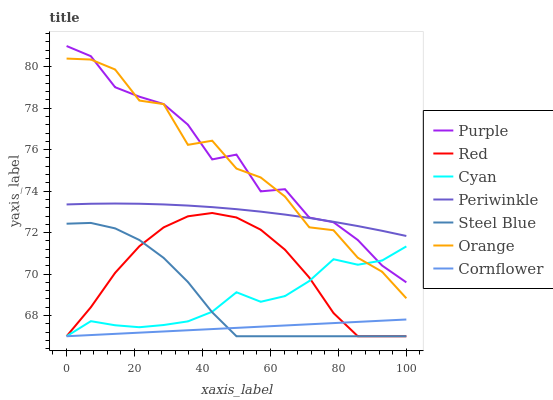Does Cornflower have the minimum area under the curve?
Answer yes or no. Yes. Does Purple have the maximum area under the curve?
Answer yes or no. Yes. Does Steel Blue have the minimum area under the curve?
Answer yes or no. No. Does Steel Blue have the maximum area under the curve?
Answer yes or no. No. Is Cornflower the smoothest?
Answer yes or no. Yes. Is Orange the roughest?
Answer yes or no. Yes. Is Purple the smoothest?
Answer yes or no. No. Is Purple the roughest?
Answer yes or no. No. Does Cornflower have the lowest value?
Answer yes or no. Yes. Does Purple have the lowest value?
Answer yes or no. No. Does Purple have the highest value?
Answer yes or no. Yes. Does Steel Blue have the highest value?
Answer yes or no. No. Is Cornflower less than Periwinkle?
Answer yes or no. Yes. Is Orange greater than Steel Blue?
Answer yes or no. Yes. Does Periwinkle intersect Purple?
Answer yes or no. Yes. Is Periwinkle less than Purple?
Answer yes or no. No. Is Periwinkle greater than Purple?
Answer yes or no. No. Does Cornflower intersect Periwinkle?
Answer yes or no. No. 